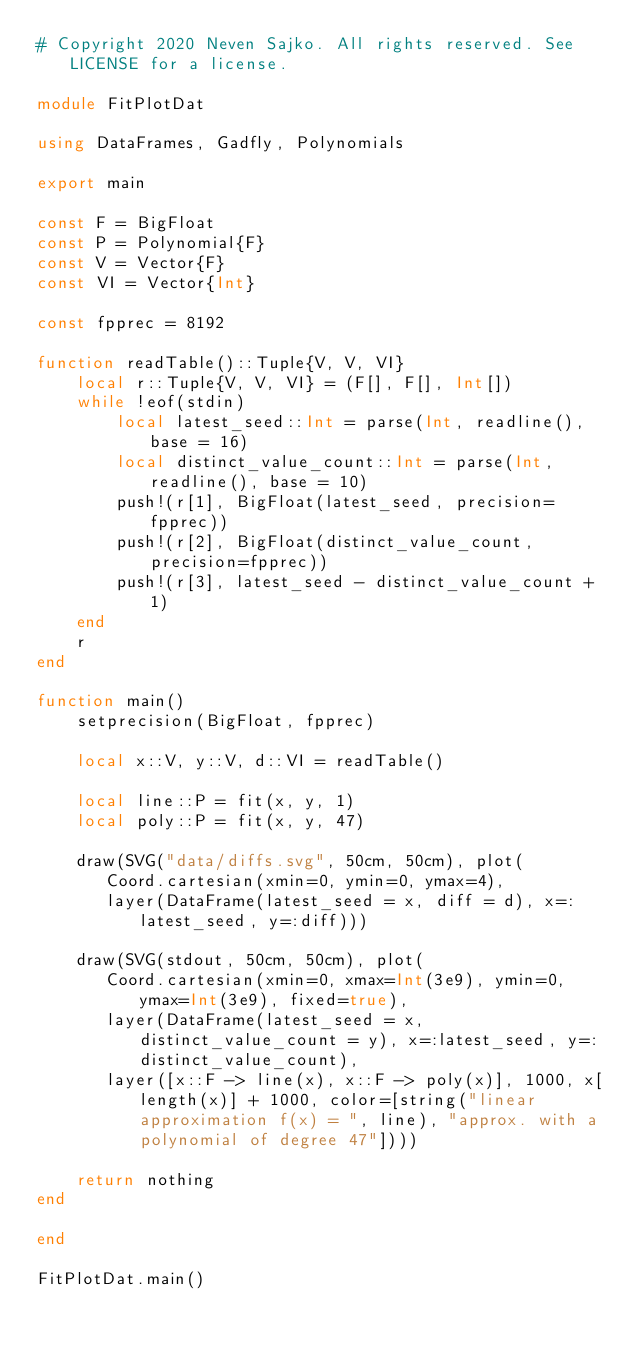<code> <loc_0><loc_0><loc_500><loc_500><_Julia_># Copyright 2020 Neven Sajko. All rights reserved. See LICENSE for a license.

module FitPlotDat

using DataFrames, Gadfly, Polynomials

export main

const F = BigFloat
const P = Polynomial{F}
const V = Vector{F}
const VI = Vector{Int}

const fpprec = 8192

function readTable()::Tuple{V, V, VI}
	local r::Tuple{V, V, VI} = (F[], F[], Int[])
	while !eof(stdin)
		local latest_seed::Int = parse(Int, readline(), base = 16)
		local distinct_value_count::Int = parse(Int, readline(), base = 10)
		push!(r[1], BigFloat(latest_seed, precision=fpprec))
		push!(r[2], BigFloat(distinct_value_count, precision=fpprec))
		push!(r[3], latest_seed - distinct_value_count + 1)
	end
	r
end

function main()
	setprecision(BigFloat, fpprec)

	local x::V, y::V, d::VI = readTable()

	local line::P = fit(x, y, 1)
	local poly::P = fit(x, y, 47)

	draw(SVG("data/diffs.svg", 50cm, 50cm), plot(
	   Coord.cartesian(xmin=0, ymin=0, ymax=4),
	   layer(DataFrame(latest_seed = x, diff = d), x=:latest_seed, y=:diff)))

	draw(SVG(stdout, 50cm, 50cm), plot(
	   Coord.cartesian(xmin=0, xmax=Int(3e9), ymin=0, ymax=Int(3e9), fixed=true),
	   layer(DataFrame(latest_seed = x, distinct_value_count = y), x=:latest_seed, y=:distinct_value_count),
	   layer([x::F -> line(x), x::F -> poly(x)], 1000, x[length(x)] + 1000, color=[string("linear approximation f(x) = ", line), "approx. with a polynomial of degree 47"])))

	return nothing
end

end

FitPlotDat.main()
</code> 